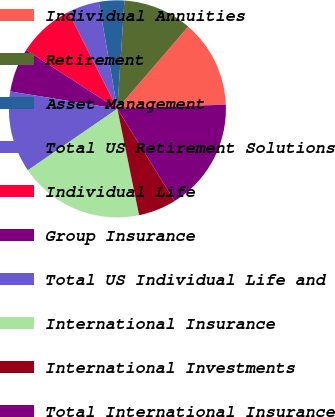Convert chart to OTSL. <chart><loc_0><loc_0><loc_500><loc_500><pie_chart><fcel>Individual Annuities<fcel>Retirement<fcel>Asset Management<fcel>Total US Retirement Solutions<fcel>Individual Life<fcel>Group Insurance<fcel>Total US Individual Life and<fcel>International Insurance<fcel>International Investments<fcel>Total International Insurance<nl><fcel>13.06%<fcel>10.28%<fcel>3.78%<fcel>4.71%<fcel>8.42%<fcel>6.56%<fcel>12.14%<fcel>18.63%<fcel>5.64%<fcel>16.78%<nl></chart> 